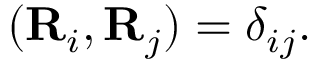Convert formula to latex. <formula><loc_0><loc_0><loc_500><loc_500>\begin{array} { r } { ( { R } _ { i } , { R } _ { j } ) = \delta _ { i j } . } \end{array}</formula> 